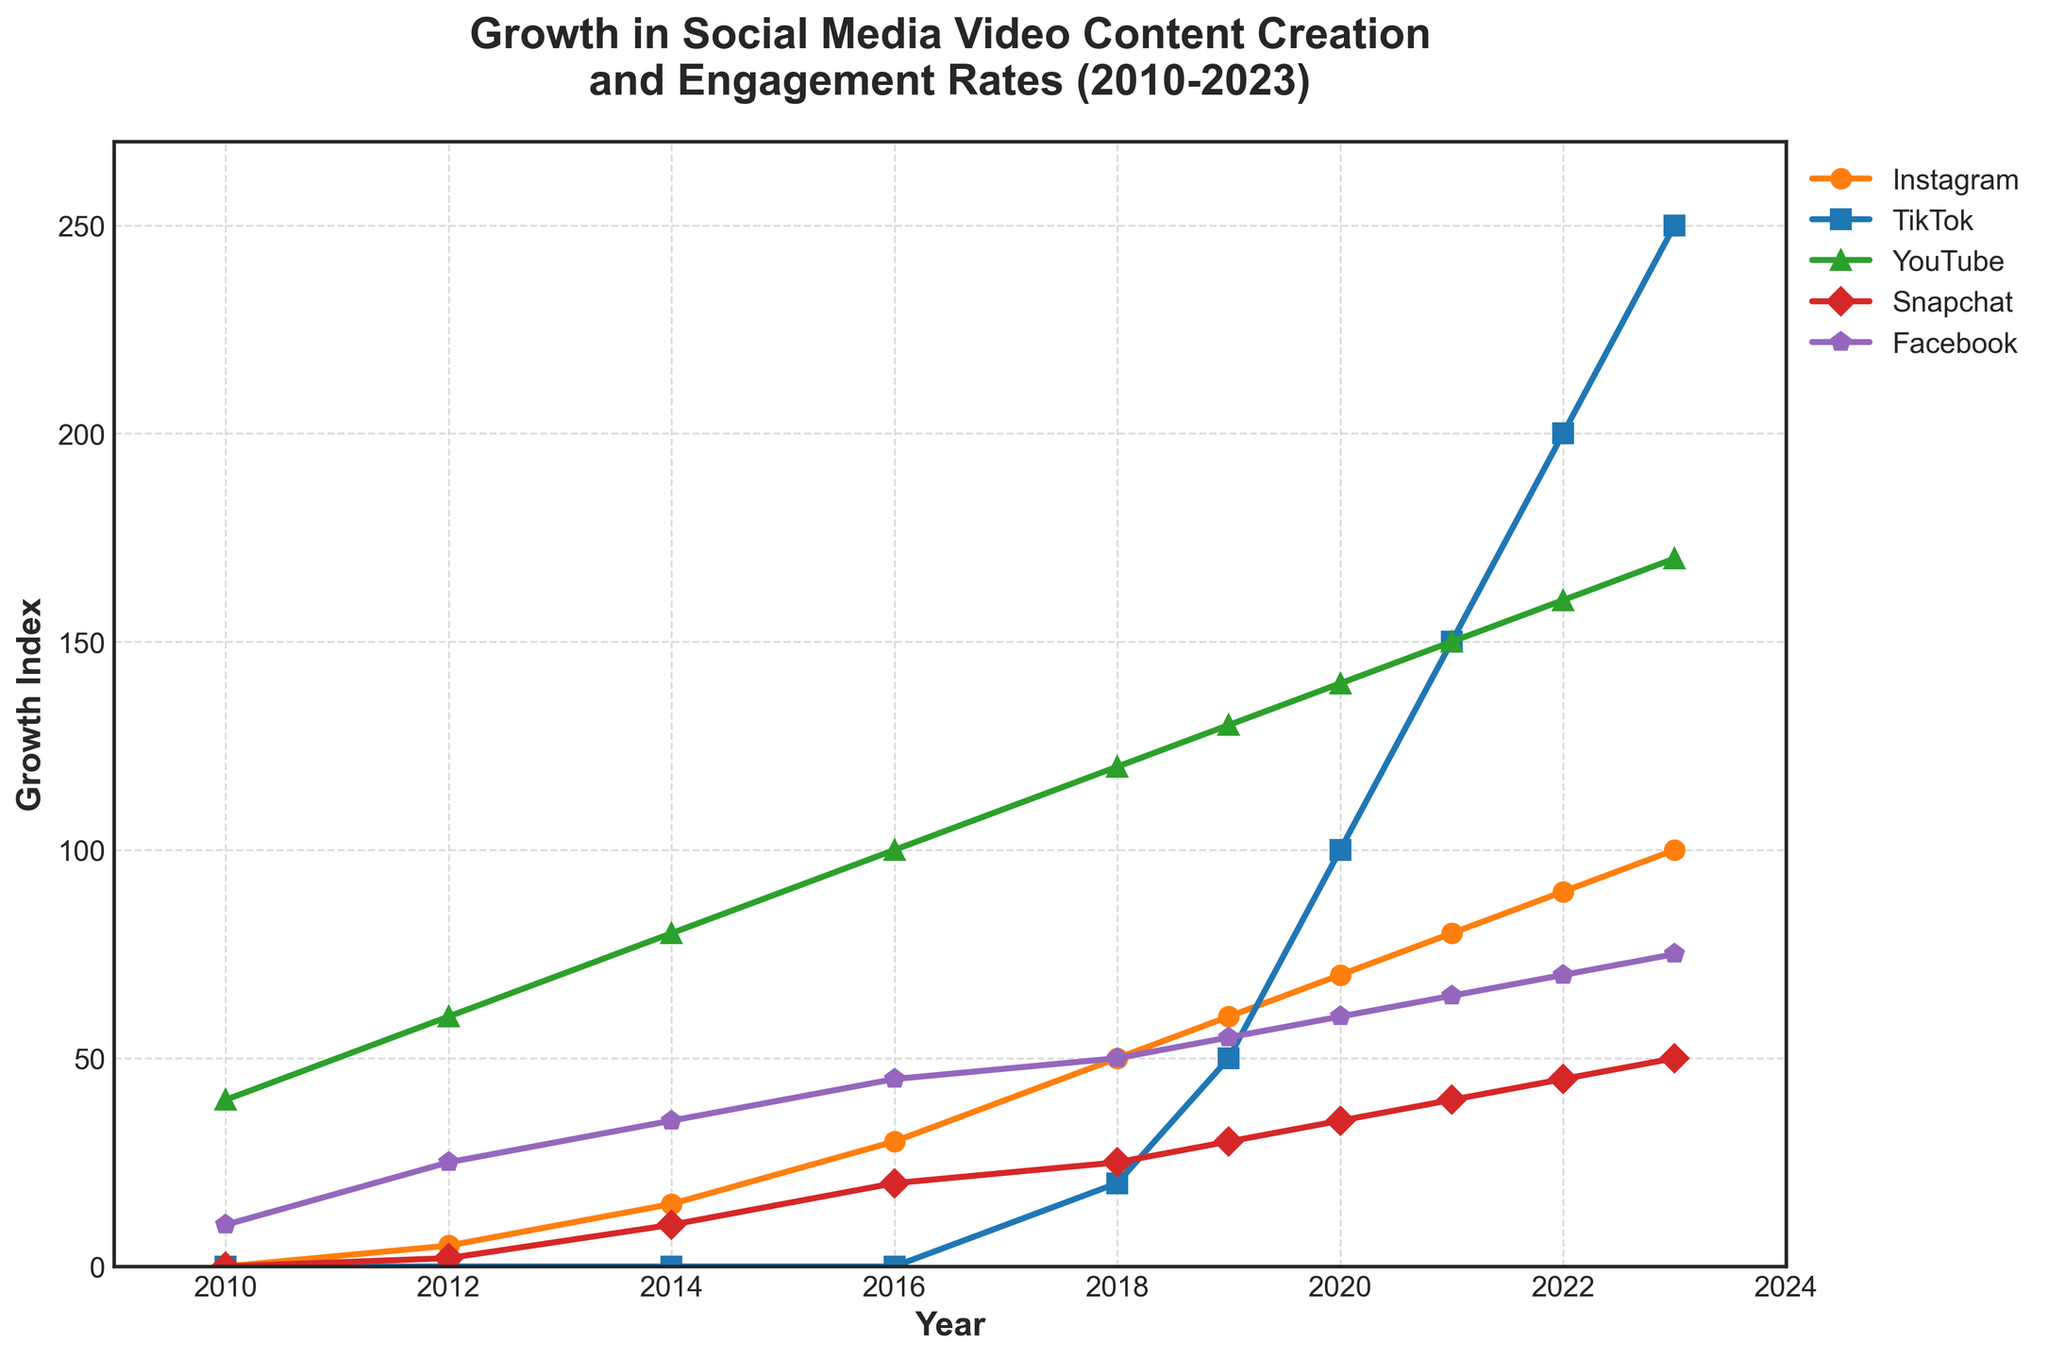What's the average growth index of Instagram from 2010 to 2023? First, note the growth index of Instagram for each year: 0, 5, 15, 30, 50, 60, 70, 80, 90, and 100. Sum these values to get 500. There are 10 years, so divide the sum by 10 to get the average.
Answer: 50 Which year did TikTok's growth index start to surpass YouTube's growth index? Observe the lines for TikTok and YouTube. TikTok's line surpasses YouTube's line in 2022 as it goes above YouTube's value of 160 while TikTok goes to 200.
Answer: 2022 How much did the growth index of Snapchat increase from 2018 to 2020? The values for Snapchat in 2018 and 2020 are 25 and 35, respectively. Subtract the 2018 value from the 2020 value: 35 - 25 = 10.
Answer: 10 What is the difference in Facebook's growth index between the years 2014 and 2023? The values for Facebook in 2014 and 2023 are 35 and 75, respectively. Subtract the 2014 value from the 2023 value: 75 - 35 = 40.
Answer: 40 Which platform had the highest growth index in 2021 and what was the value? By looking at the growth index values for 2021, TikTok had the highest value at 150.
Answer: TikTok, 150 How did Instagram's growth trend compare to TikTok's from 2018 to 2023? Instagram's values were 50, 60, 70, 80, 90, and 100 from 2018 to 2023, showing steady growth. TikTok's values were 20, 50, 100, 150, 200, and 250, showing rapid growth. TikTok's growth rate was much faster.
Answer: TikTok's growth was faster What was the total growth index of YouTube from 2014 to 2023? Sum the YouTube values: 80 for 2014, 100 for 2016, 120 for 2018, 130 for 2019, 140 for 2020, 150 for 2021, 160 for 2022, and 170 for 2023. The total is 1050.
Answer: 1050 How do the growth trends of Snapchat and Facebook compare in terms of steepness between 2018 and 2023? Snapchat grew from 25 to 50, an increase of 25; Facebook grew from 50 to 75, an increase of 25 as well. The growth rates are thus similar in terms of steepness for this period.
Answer: Similar In which year did Instagram's growth index reach 70? The growth index of Instagram reached 70 in 2020.
Answer: 2020 Across all years, which platform showed the most significant jump in growth index between two consecutive years? TikTok showed the most significant jump between 2021 and 2022, increasing from 150 to 200, a change of 50.
Answer: TikTok between 2021 and 2022 